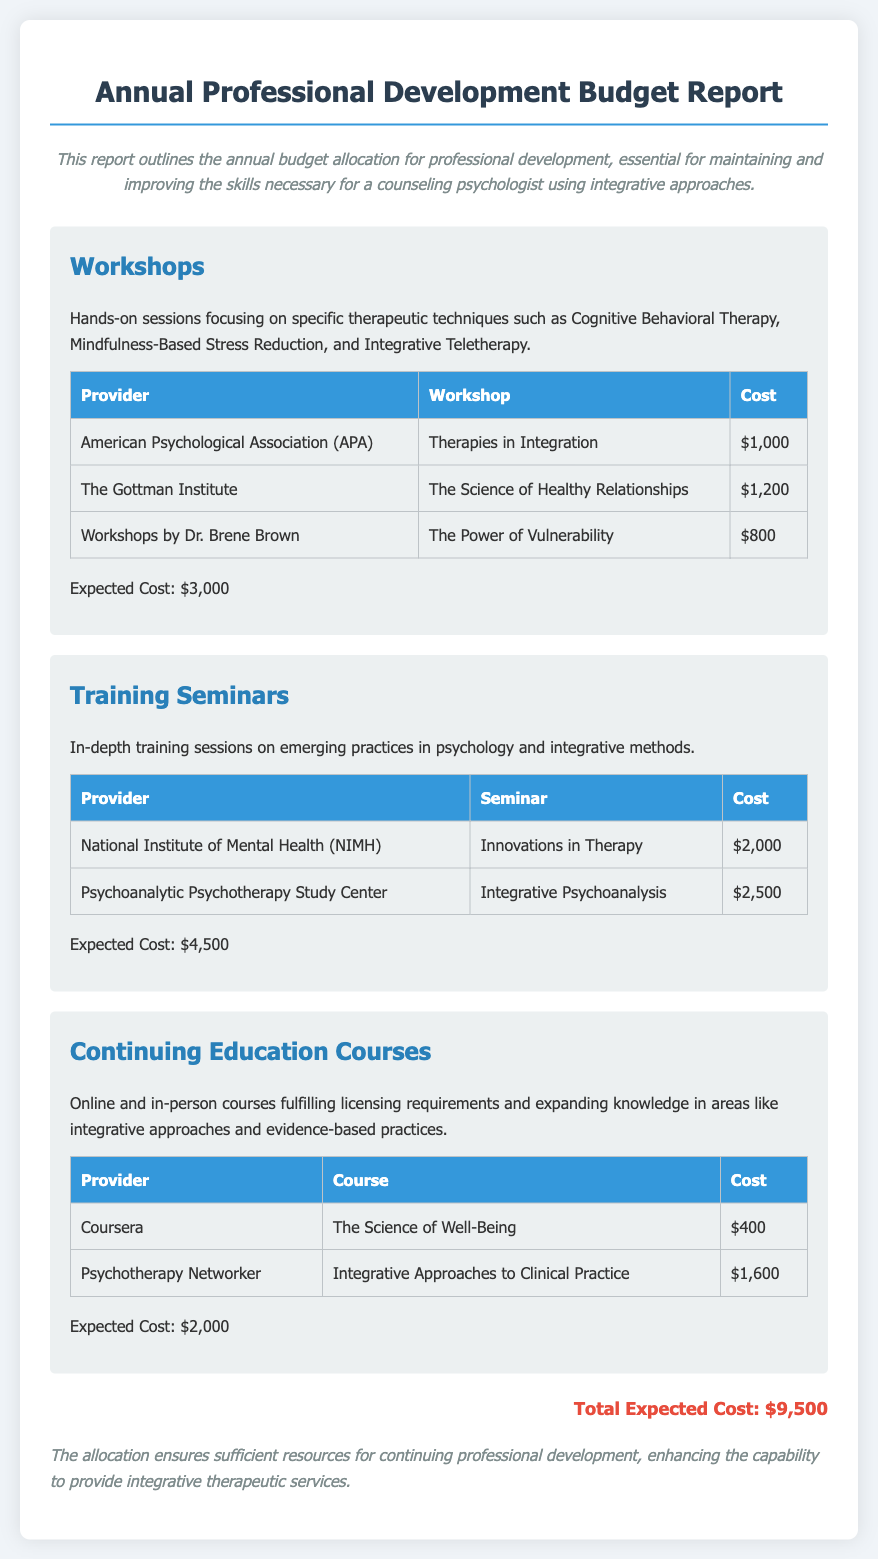what is the total expected cost? The total expected cost is mentioned at the end of the report, summarizing all the allocations.
Answer: $9,500 who is providing the seminar on innovations in therapy? This information can be found in the training seminars section of the document.
Answer: National Institute of Mental Health (NIMH) how much does the course "Integrative Approaches to Clinical Practice" cost? The cost for this specific course is listed in the continuing education courses section.
Answer: $1,600 what are the names of the workshop providers? This question can be answered by extracting the names listed under workshops in the document.
Answer: American Psychological Association (APA), The Gottman Institute, Workshops by Dr. Brene Brown what is the expected cost for workshops? The expected cost for workshops is specified in the workshops section of the document.
Answer: $3,000 how many training seminars are detailed in the report? This can be determined by counting the number of training seminars listed in the respective section.
Answer: 2 which provider offers the course "The Science of Well-Being"? This provider is mentioned in the continuing education courses section.
Answer: Coursera what type of training do the seminars focus on? The type of training is described in the introduction of the training seminars section.
Answer: Emerging practices in psychology and integrative methods what are the two topics covered in workshops mentioned? The document outlines specific topics under workshops, which are mentioned in the category description.
Answer: Cognitive Behavioral Therapy, Mindfulness-Based Stress Reduction 